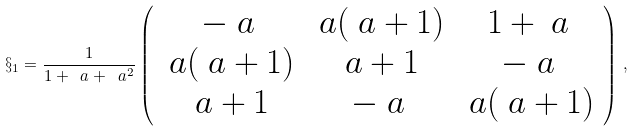Convert formula to latex. <formula><loc_0><loc_0><loc_500><loc_500>\S _ { 1 } = \frac { 1 } { 1 + \ a + \ a ^ { 2 } } \left ( \begin{array} { c c c } - \ a & \ a ( \ a + 1 ) & 1 + \ a \\ \ a ( \ a + 1 ) & \ a + 1 & - \ a \\ \ a + 1 & - \ a & \ a ( \ a + 1 ) \end{array} \right ) \, ,</formula> 